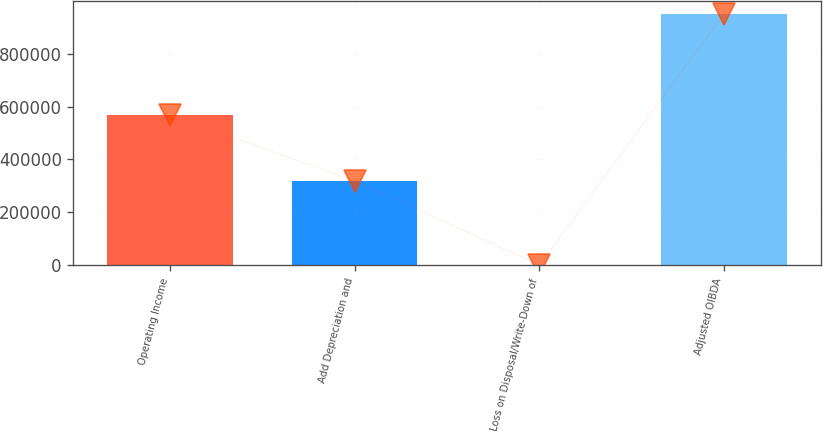<chart> <loc_0><loc_0><loc_500><loc_500><bar_chart><fcel>Operating Income<fcel>Add Depreciation and<fcel>Loss on Disposal/Write-Down of<fcel>Adjusted OIBDA<nl><fcel>566818<fcel>319499<fcel>995<fcel>949339<nl></chart> 